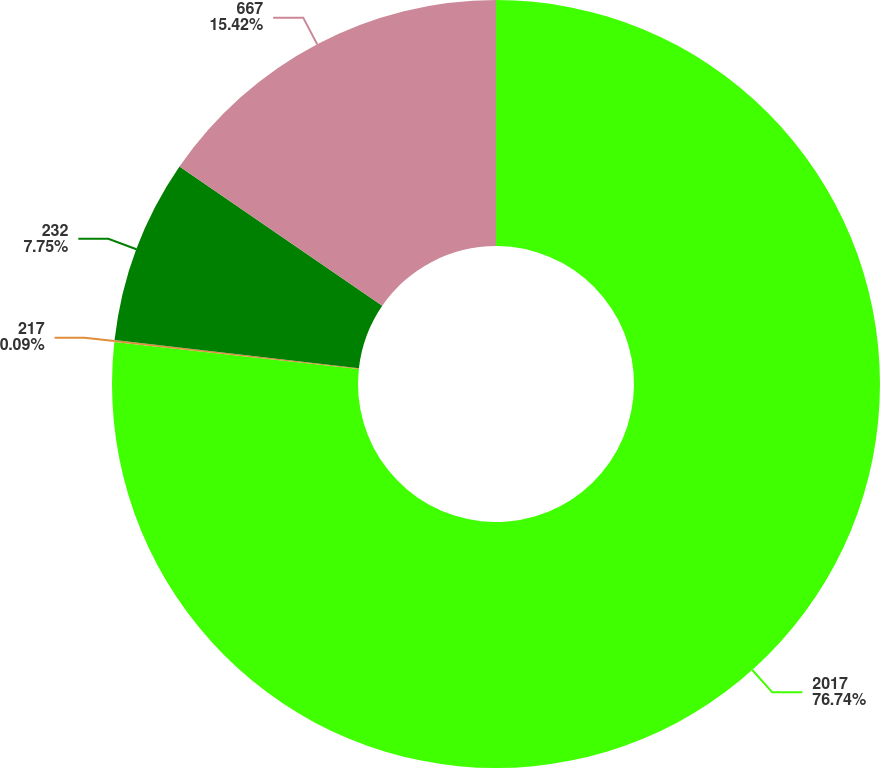Convert chart. <chart><loc_0><loc_0><loc_500><loc_500><pie_chart><fcel>2017<fcel>217<fcel>232<fcel>667<nl><fcel>76.74%<fcel>0.09%<fcel>7.75%<fcel>15.42%<nl></chart> 